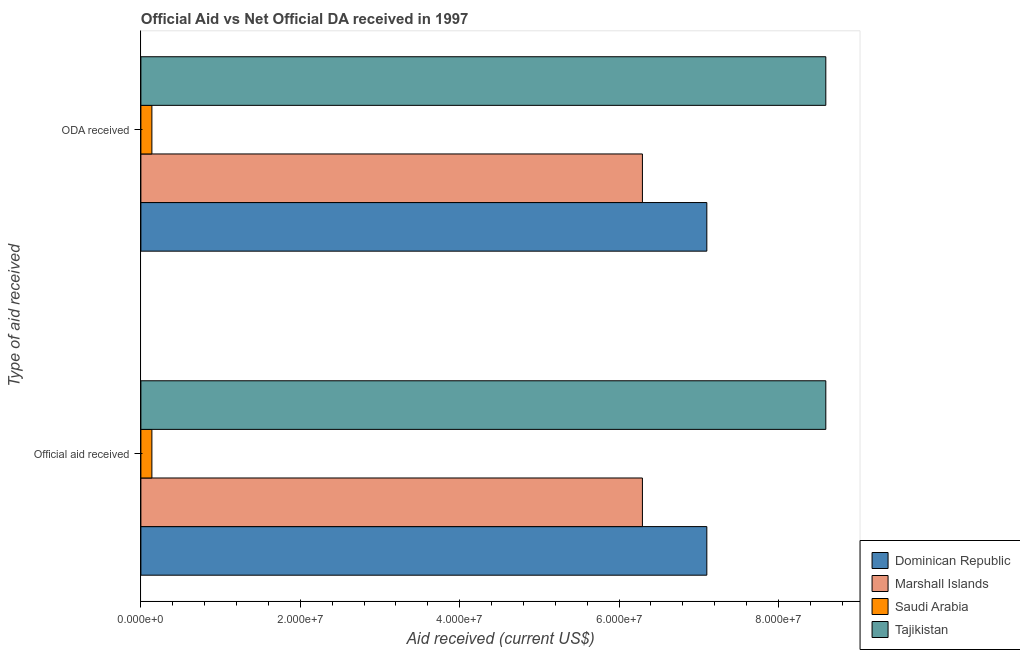Are the number of bars per tick equal to the number of legend labels?
Your answer should be compact. Yes. How many bars are there on the 1st tick from the top?
Ensure brevity in your answer.  4. How many bars are there on the 1st tick from the bottom?
Your answer should be very brief. 4. What is the label of the 1st group of bars from the top?
Your response must be concise. ODA received. What is the official aid received in Marshall Islands?
Keep it short and to the point. 6.29e+07. Across all countries, what is the maximum oda received?
Your response must be concise. 8.59e+07. Across all countries, what is the minimum oda received?
Provide a succinct answer. 1.38e+06. In which country was the official aid received maximum?
Ensure brevity in your answer.  Tajikistan. In which country was the oda received minimum?
Give a very brief answer. Saudi Arabia. What is the total oda received in the graph?
Provide a succinct answer. 2.21e+08. What is the difference between the oda received in Saudi Arabia and that in Dominican Republic?
Provide a succinct answer. -6.96e+07. What is the difference between the oda received in Marshall Islands and the official aid received in Tajikistan?
Your response must be concise. -2.30e+07. What is the average official aid received per country?
Your answer should be very brief. 5.53e+07. What is the difference between the official aid received and oda received in Dominican Republic?
Your answer should be compact. 0. In how many countries, is the official aid received greater than 8000000 US$?
Your answer should be compact. 3. What is the ratio of the oda received in Tajikistan to that in Saudi Arabia?
Offer a very short reply. 62.28. What does the 2nd bar from the top in ODA received represents?
Provide a succinct answer. Saudi Arabia. What does the 1st bar from the bottom in Official aid received represents?
Provide a succinct answer. Dominican Republic. How many bars are there?
Your answer should be compact. 8. Are all the bars in the graph horizontal?
Offer a terse response. Yes. What is the difference between two consecutive major ticks on the X-axis?
Your response must be concise. 2.00e+07. Does the graph contain grids?
Your answer should be compact. No. How many legend labels are there?
Your response must be concise. 4. How are the legend labels stacked?
Offer a very short reply. Vertical. What is the title of the graph?
Ensure brevity in your answer.  Official Aid vs Net Official DA received in 1997 . What is the label or title of the X-axis?
Provide a succinct answer. Aid received (current US$). What is the label or title of the Y-axis?
Give a very brief answer. Type of aid received. What is the Aid received (current US$) in Dominican Republic in Official aid received?
Make the answer very short. 7.10e+07. What is the Aid received (current US$) in Marshall Islands in Official aid received?
Keep it short and to the point. 6.29e+07. What is the Aid received (current US$) in Saudi Arabia in Official aid received?
Your answer should be compact. 1.38e+06. What is the Aid received (current US$) of Tajikistan in Official aid received?
Give a very brief answer. 8.59e+07. What is the Aid received (current US$) of Dominican Republic in ODA received?
Keep it short and to the point. 7.10e+07. What is the Aid received (current US$) in Marshall Islands in ODA received?
Your answer should be very brief. 6.29e+07. What is the Aid received (current US$) of Saudi Arabia in ODA received?
Give a very brief answer. 1.38e+06. What is the Aid received (current US$) in Tajikistan in ODA received?
Offer a terse response. 8.59e+07. Across all Type of aid received, what is the maximum Aid received (current US$) in Dominican Republic?
Give a very brief answer. 7.10e+07. Across all Type of aid received, what is the maximum Aid received (current US$) in Marshall Islands?
Offer a very short reply. 6.29e+07. Across all Type of aid received, what is the maximum Aid received (current US$) in Saudi Arabia?
Offer a very short reply. 1.38e+06. Across all Type of aid received, what is the maximum Aid received (current US$) of Tajikistan?
Offer a terse response. 8.59e+07. Across all Type of aid received, what is the minimum Aid received (current US$) of Dominican Republic?
Give a very brief answer. 7.10e+07. Across all Type of aid received, what is the minimum Aid received (current US$) of Marshall Islands?
Offer a terse response. 6.29e+07. Across all Type of aid received, what is the minimum Aid received (current US$) in Saudi Arabia?
Provide a succinct answer. 1.38e+06. Across all Type of aid received, what is the minimum Aid received (current US$) of Tajikistan?
Make the answer very short. 8.59e+07. What is the total Aid received (current US$) of Dominican Republic in the graph?
Your answer should be compact. 1.42e+08. What is the total Aid received (current US$) of Marshall Islands in the graph?
Your answer should be compact. 1.26e+08. What is the total Aid received (current US$) in Saudi Arabia in the graph?
Keep it short and to the point. 2.76e+06. What is the total Aid received (current US$) of Tajikistan in the graph?
Provide a short and direct response. 1.72e+08. What is the difference between the Aid received (current US$) of Marshall Islands in Official aid received and that in ODA received?
Provide a short and direct response. 0. What is the difference between the Aid received (current US$) of Saudi Arabia in Official aid received and that in ODA received?
Offer a very short reply. 0. What is the difference between the Aid received (current US$) of Dominican Republic in Official aid received and the Aid received (current US$) of Marshall Islands in ODA received?
Your answer should be very brief. 8.08e+06. What is the difference between the Aid received (current US$) in Dominican Republic in Official aid received and the Aid received (current US$) in Saudi Arabia in ODA received?
Ensure brevity in your answer.  6.96e+07. What is the difference between the Aid received (current US$) of Dominican Republic in Official aid received and the Aid received (current US$) of Tajikistan in ODA received?
Give a very brief answer. -1.49e+07. What is the difference between the Aid received (current US$) in Marshall Islands in Official aid received and the Aid received (current US$) in Saudi Arabia in ODA received?
Ensure brevity in your answer.  6.16e+07. What is the difference between the Aid received (current US$) of Marshall Islands in Official aid received and the Aid received (current US$) of Tajikistan in ODA received?
Your answer should be very brief. -2.30e+07. What is the difference between the Aid received (current US$) in Saudi Arabia in Official aid received and the Aid received (current US$) in Tajikistan in ODA received?
Give a very brief answer. -8.46e+07. What is the average Aid received (current US$) in Dominican Republic per Type of aid received?
Your answer should be very brief. 7.10e+07. What is the average Aid received (current US$) in Marshall Islands per Type of aid received?
Keep it short and to the point. 6.29e+07. What is the average Aid received (current US$) in Saudi Arabia per Type of aid received?
Provide a succinct answer. 1.38e+06. What is the average Aid received (current US$) of Tajikistan per Type of aid received?
Ensure brevity in your answer.  8.59e+07. What is the difference between the Aid received (current US$) of Dominican Republic and Aid received (current US$) of Marshall Islands in Official aid received?
Your response must be concise. 8.08e+06. What is the difference between the Aid received (current US$) in Dominican Republic and Aid received (current US$) in Saudi Arabia in Official aid received?
Offer a terse response. 6.96e+07. What is the difference between the Aid received (current US$) in Dominican Republic and Aid received (current US$) in Tajikistan in Official aid received?
Your answer should be very brief. -1.49e+07. What is the difference between the Aid received (current US$) of Marshall Islands and Aid received (current US$) of Saudi Arabia in Official aid received?
Make the answer very short. 6.16e+07. What is the difference between the Aid received (current US$) of Marshall Islands and Aid received (current US$) of Tajikistan in Official aid received?
Your answer should be very brief. -2.30e+07. What is the difference between the Aid received (current US$) of Saudi Arabia and Aid received (current US$) of Tajikistan in Official aid received?
Your response must be concise. -8.46e+07. What is the difference between the Aid received (current US$) of Dominican Republic and Aid received (current US$) of Marshall Islands in ODA received?
Provide a succinct answer. 8.08e+06. What is the difference between the Aid received (current US$) of Dominican Republic and Aid received (current US$) of Saudi Arabia in ODA received?
Your response must be concise. 6.96e+07. What is the difference between the Aid received (current US$) of Dominican Republic and Aid received (current US$) of Tajikistan in ODA received?
Provide a short and direct response. -1.49e+07. What is the difference between the Aid received (current US$) in Marshall Islands and Aid received (current US$) in Saudi Arabia in ODA received?
Make the answer very short. 6.16e+07. What is the difference between the Aid received (current US$) of Marshall Islands and Aid received (current US$) of Tajikistan in ODA received?
Your response must be concise. -2.30e+07. What is the difference between the Aid received (current US$) in Saudi Arabia and Aid received (current US$) in Tajikistan in ODA received?
Keep it short and to the point. -8.46e+07. What is the ratio of the Aid received (current US$) of Dominican Republic in Official aid received to that in ODA received?
Provide a succinct answer. 1. What is the ratio of the Aid received (current US$) of Marshall Islands in Official aid received to that in ODA received?
Keep it short and to the point. 1. What is the ratio of the Aid received (current US$) in Saudi Arabia in Official aid received to that in ODA received?
Your answer should be very brief. 1. What is the ratio of the Aid received (current US$) of Tajikistan in Official aid received to that in ODA received?
Provide a short and direct response. 1. What is the difference between the highest and the second highest Aid received (current US$) in Saudi Arabia?
Keep it short and to the point. 0. What is the difference between the highest and the lowest Aid received (current US$) in Saudi Arabia?
Offer a terse response. 0. 